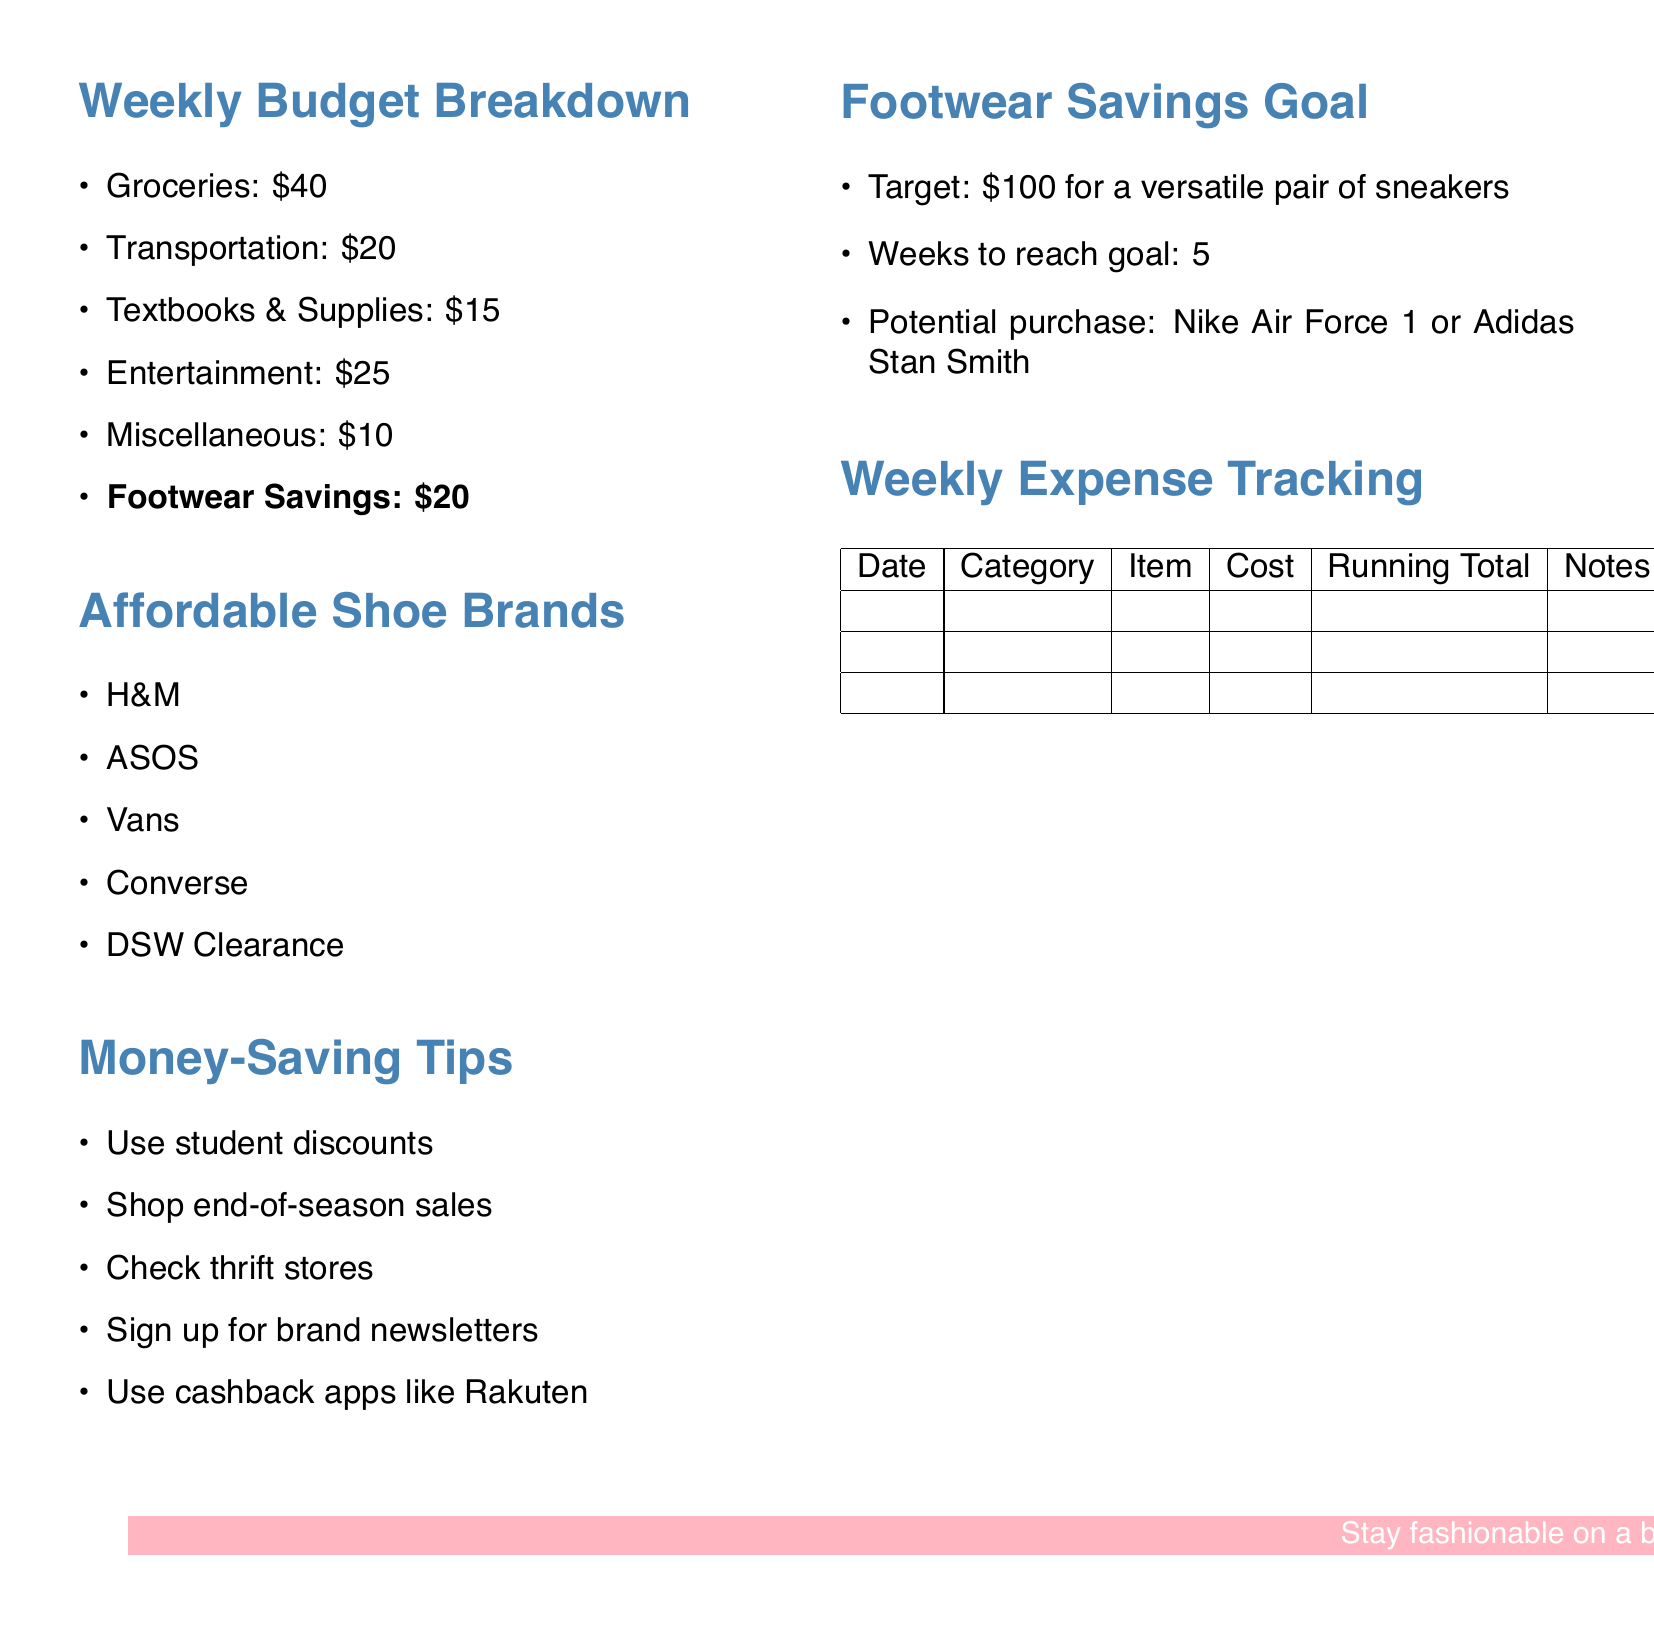What is the total budget for footwear savings? The budget for footwear savings is explicitly stated in the document as $20.
Answer: $20 How many weeks are needed to reach the footwear savings goal? The document mentions that it will take 5 weeks to reach the savings goal.
Answer: 5 What is the target amount for the footwear savings goal? The target amount for the footwear savings goal is set at $100.
Answer: $100 Name one brand listed under affordable shoe brands. The document lists several brands under affordable shoe options, including H&M as one of them.
Answer: H&M What is one money-saving tip mentioned in the document? The document includes several money-saving tips, one of which is to use student discounts.
Answer: Use student discounts What are the potential sneaker purchases listed in the savings goal? The document suggests two potential sneaker purchases: Nike Air Force 1 and Adidas Stan Smith.
Answer: Nike Air Force 1 or Adidas Stan Smith What is the total cost allocated for groceries? The total cost allocated for groceries is clearly listed as $40.
Answer: $40 Which category has the highest budget allocation? The budget allocation for entertainment is the highest at $25.
Answer: Entertainment How many items are there in the weekly expense tracking table? The weekly expense tracking table currently has 6 item placeholders listed in the column headers.
Answer: 6 